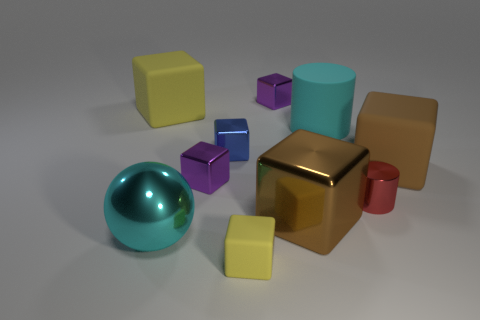Are there more tiny purple metallic blocks behind the big yellow matte cube than brown rubber cubes that are on the left side of the tiny rubber object?
Offer a very short reply. Yes. What number of other things are there of the same size as the cyan cylinder?
Your response must be concise. 4. Is the shape of the small yellow matte object the same as the large brown thing in front of the red cylinder?
Offer a very short reply. Yes. How many matte things are either cyan spheres or big yellow cylinders?
Your response must be concise. 0. Is there a rubber cube of the same color as the small matte thing?
Keep it short and to the point. Yes. Is there a big cyan matte object?
Offer a very short reply. Yes. Is the brown shiny object the same shape as the cyan shiny thing?
Your response must be concise. No. How many small objects are either blue rubber things or cylinders?
Provide a short and direct response. 1. The metal ball is what color?
Your answer should be very brief. Cyan. There is a large rubber object to the left of the yellow matte object right of the sphere; what shape is it?
Offer a terse response. Cube. 